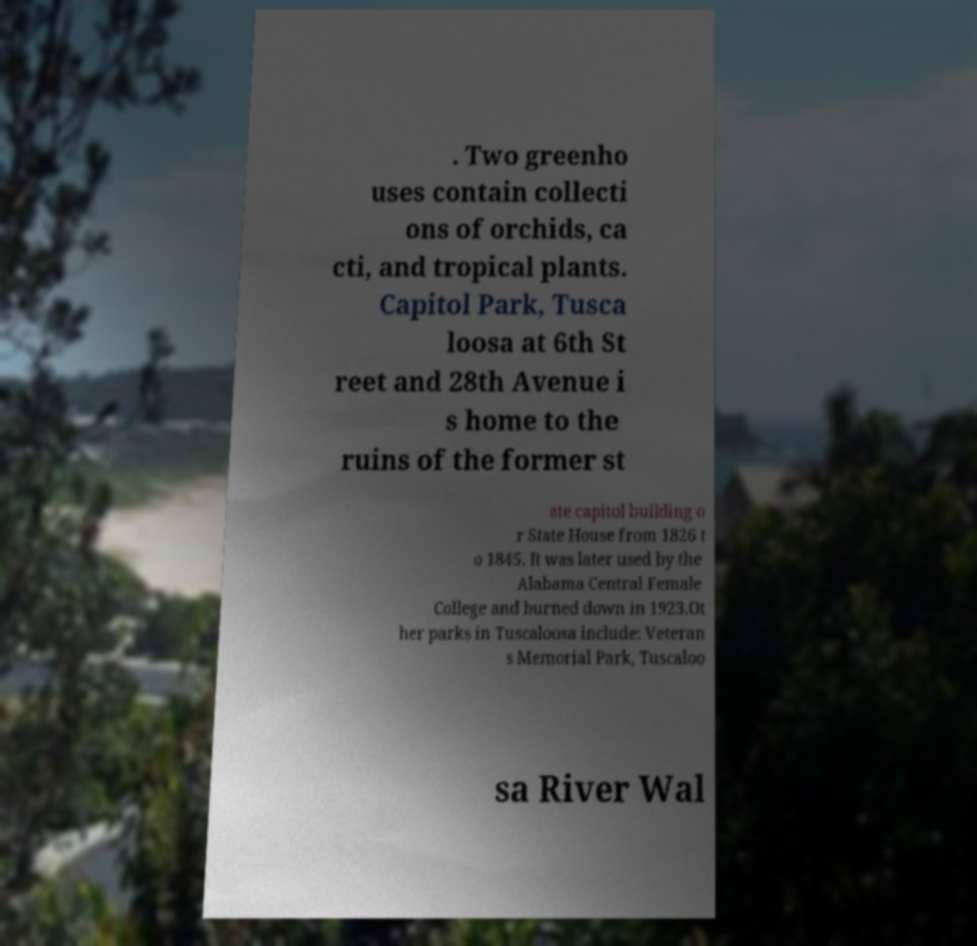Could you assist in decoding the text presented in this image and type it out clearly? . Two greenho uses contain collecti ons of orchids, ca cti, and tropical plants. Capitol Park, Tusca loosa at 6th St reet and 28th Avenue i s home to the ruins of the former st ate capitol building o r State House from 1826 t o 1845. It was later used by the Alabama Central Female College and burned down in 1923.Ot her parks in Tuscaloosa include: Veteran s Memorial Park, Tuscaloo sa River Wal 